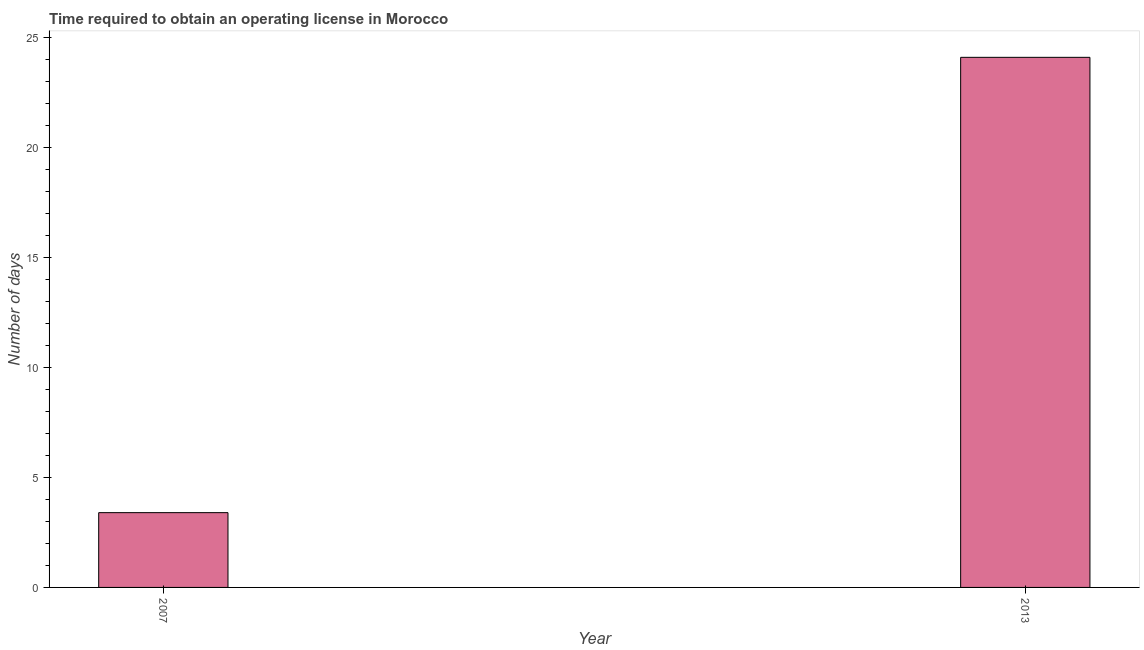What is the title of the graph?
Keep it short and to the point. Time required to obtain an operating license in Morocco. What is the label or title of the Y-axis?
Your response must be concise. Number of days. What is the number of days to obtain operating license in 2007?
Ensure brevity in your answer.  3.4. Across all years, what is the maximum number of days to obtain operating license?
Provide a short and direct response. 24.1. Across all years, what is the minimum number of days to obtain operating license?
Make the answer very short. 3.4. In which year was the number of days to obtain operating license maximum?
Give a very brief answer. 2013. What is the difference between the number of days to obtain operating license in 2007 and 2013?
Your answer should be very brief. -20.7. What is the average number of days to obtain operating license per year?
Provide a succinct answer. 13.75. What is the median number of days to obtain operating license?
Your answer should be compact. 13.75. In how many years, is the number of days to obtain operating license greater than 17 days?
Offer a very short reply. 1. What is the ratio of the number of days to obtain operating license in 2007 to that in 2013?
Keep it short and to the point. 0.14. Is the number of days to obtain operating license in 2007 less than that in 2013?
Provide a short and direct response. Yes. In how many years, is the number of days to obtain operating license greater than the average number of days to obtain operating license taken over all years?
Give a very brief answer. 1. How many bars are there?
Give a very brief answer. 2. Are all the bars in the graph horizontal?
Offer a terse response. No. How many years are there in the graph?
Provide a succinct answer. 2. What is the difference between two consecutive major ticks on the Y-axis?
Your answer should be very brief. 5. What is the Number of days of 2007?
Your response must be concise. 3.4. What is the Number of days in 2013?
Make the answer very short. 24.1. What is the difference between the Number of days in 2007 and 2013?
Keep it short and to the point. -20.7. What is the ratio of the Number of days in 2007 to that in 2013?
Provide a succinct answer. 0.14. 